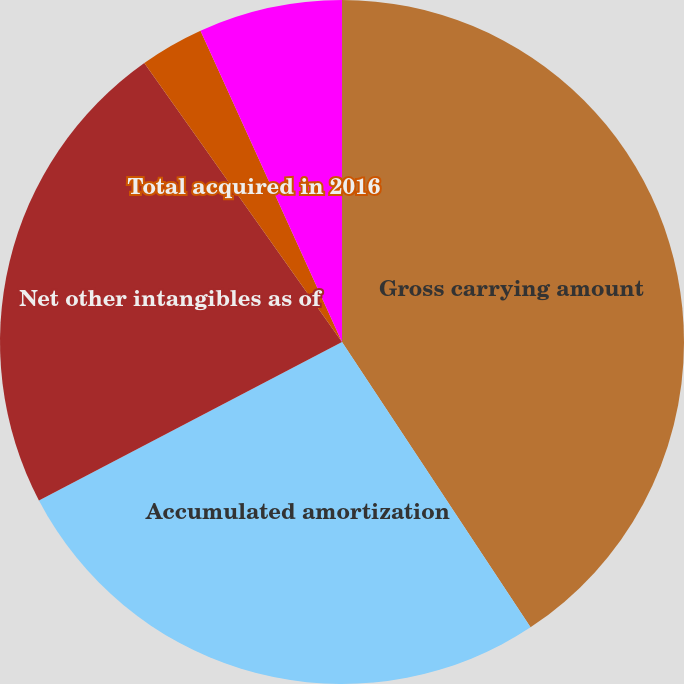<chart> <loc_0><loc_0><loc_500><loc_500><pie_chart><fcel>Gross carrying amount<fcel>Accumulated amortization<fcel>Net other intangibles as of<fcel>Total acquired in 2016<fcel>Weighted average amortization<nl><fcel>40.71%<fcel>26.63%<fcel>22.86%<fcel>3.02%<fcel>6.79%<nl></chart> 